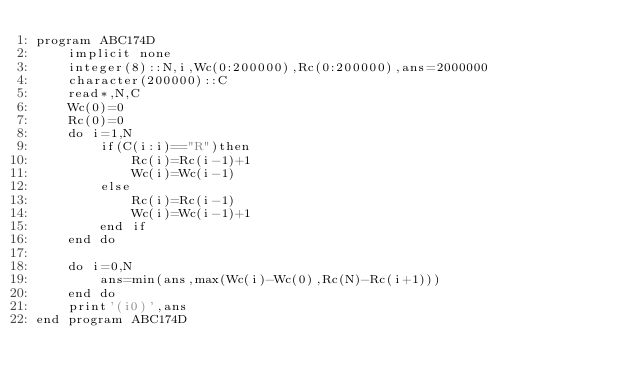Convert code to text. <code><loc_0><loc_0><loc_500><loc_500><_FORTRAN_>program ABC174D
    implicit none
    integer(8)::N,i,Wc(0:200000),Rc(0:200000),ans=2000000
    character(200000)::C
    read*,N,C
    Wc(0)=0
    Rc(0)=0
    do i=1,N
        if(C(i:i)=="R")then
            Rc(i)=Rc(i-1)+1
            Wc(i)=Wc(i-1)
        else
            Rc(i)=Rc(i-1)
            Wc(i)=Wc(i-1)+1
        end if
    end do

    do i=0,N
        ans=min(ans,max(Wc(i)-Wc(0),Rc(N)-Rc(i+1)))
    end do
    print'(i0)',ans
end program ABC174D</code> 